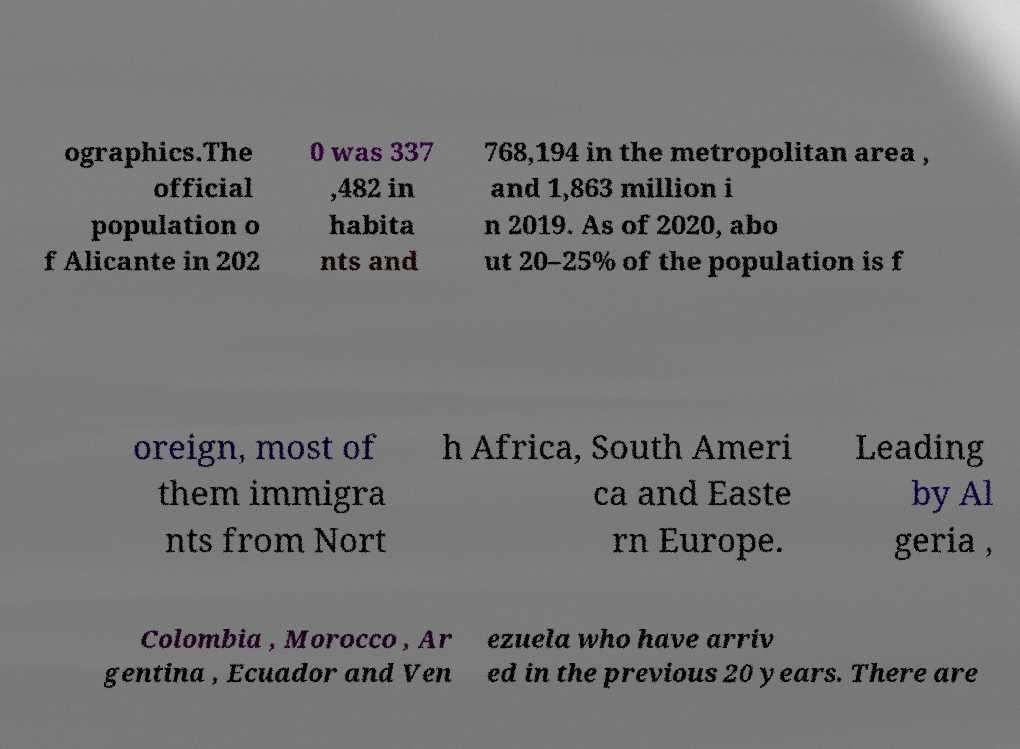Could you extract and type out the text from this image? ographics.The official population o f Alicante in 202 0 was 337 ,482 in habita nts and 768,194 in the metropolitan area , and 1,863 million i n 2019. As of 2020, abo ut 20–25% of the population is f oreign, most of them immigra nts from Nort h Africa, South Ameri ca and Easte rn Europe. Leading by Al geria , Colombia , Morocco , Ar gentina , Ecuador and Ven ezuela who have arriv ed in the previous 20 years. There are 